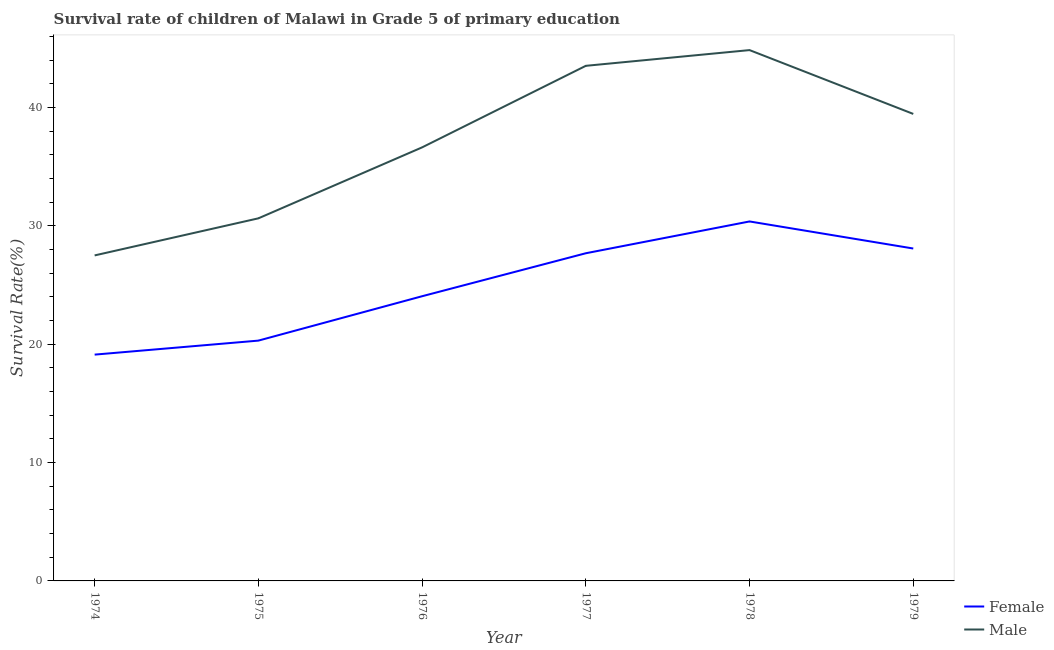How many different coloured lines are there?
Give a very brief answer. 2. Does the line corresponding to survival rate of female students in primary education intersect with the line corresponding to survival rate of male students in primary education?
Your response must be concise. No. Is the number of lines equal to the number of legend labels?
Keep it short and to the point. Yes. What is the survival rate of female students in primary education in 1979?
Ensure brevity in your answer.  28.09. Across all years, what is the maximum survival rate of female students in primary education?
Your response must be concise. 30.38. Across all years, what is the minimum survival rate of male students in primary education?
Ensure brevity in your answer.  27.51. In which year was the survival rate of female students in primary education maximum?
Ensure brevity in your answer.  1978. In which year was the survival rate of male students in primary education minimum?
Your answer should be very brief. 1974. What is the total survival rate of male students in primary education in the graph?
Make the answer very short. 222.64. What is the difference between the survival rate of male students in primary education in 1975 and that in 1976?
Provide a short and direct response. -6. What is the difference between the survival rate of female students in primary education in 1978 and the survival rate of male students in primary education in 1975?
Offer a terse response. -0.26. What is the average survival rate of female students in primary education per year?
Your answer should be compact. 24.94. In the year 1976, what is the difference between the survival rate of female students in primary education and survival rate of male students in primary education?
Offer a terse response. -12.58. In how many years, is the survival rate of female students in primary education greater than 16 %?
Your answer should be very brief. 6. What is the ratio of the survival rate of female students in primary education in 1975 to that in 1977?
Make the answer very short. 0.73. Is the difference between the survival rate of female students in primary education in 1978 and 1979 greater than the difference between the survival rate of male students in primary education in 1978 and 1979?
Keep it short and to the point. No. What is the difference between the highest and the second highest survival rate of male students in primary education?
Provide a short and direct response. 1.33. What is the difference between the highest and the lowest survival rate of male students in primary education?
Your response must be concise. 17.35. In how many years, is the survival rate of male students in primary education greater than the average survival rate of male students in primary education taken over all years?
Provide a succinct answer. 3. Is the sum of the survival rate of female students in primary education in 1976 and 1977 greater than the maximum survival rate of male students in primary education across all years?
Give a very brief answer. Yes. Does the survival rate of female students in primary education monotonically increase over the years?
Offer a very short reply. No. What is the difference between two consecutive major ticks on the Y-axis?
Your response must be concise. 10. Does the graph contain any zero values?
Your answer should be very brief. No. What is the title of the graph?
Your response must be concise. Survival rate of children of Malawi in Grade 5 of primary education. What is the label or title of the X-axis?
Provide a short and direct response. Year. What is the label or title of the Y-axis?
Ensure brevity in your answer.  Survival Rate(%). What is the Survival Rate(%) of Female in 1974?
Give a very brief answer. 19.12. What is the Survival Rate(%) of Male in 1974?
Give a very brief answer. 27.51. What is the Survival Rate(%) in Female in 1975?
Keep it short and to the point. 20.31. What is the Survival Rate(%) of Male in 1975?
Offer a terse response. 30.64. What is the Survival Rate(%) in Female in 1976?
Give a very brief answer. 24.06. What is the Survival Rate(%) of Male in 1976?
Provide a short and direct response. 36.64. What is the Survival Rate(%) of Female in 1977?
Ensure brevity in your answer.  27.69. What is the Survival Rate(%) in Male in 1977?
Provide a short and direct response. 43.53. What is the Survival Rate(%) of Female in 1978?
Provide a succinct answer. 30.38. What is the Survival Rate(%) in Male in 1978?
Provide a short and direct response. 44.86. What is the Survival Rate(%) of Female in 1979?
Give a very brief answer. 28.09. What is the Survival Rate(%) in Male in 1979?
Provide a short and direct response. 39.47. Across all years, what is the maximum Survival Rate(%) in Female?
Your answer should be very brief. 30.38. Across all years, what is the maximum Survival Rate(%) of Male?
Your answer should be very brief. 44.86. Across all years, what is the minimum Survival Rate(%) in Female?
Your response must be concise. 19.12. Across all years, what is the minimum Survival Rate(%) of Male?
Offer a terse response. 27.51. What is the total Survival Rate(%) of Female in the graph?
Ensure brevity in your answer.  149.65. What is the total Survival Rate(%) in Male in the graph?
Your answer should be compact. 222.64. What is the difference between the Survival Rate(%) of Female in 1974 and that in 1975?
Your answer should be very brief. -1.18. What is the difference between the Survival Rate(%) in Male in 1974 and that in 1975?
Offer a terse response. -3.13. What is the difference between the Survival Rate(%) in Female in 1974 and that in 1976?
Your answer should be compact. -4.93. What is the difference between the Survival Rate(%) of Male in 1974 and that in 1976?
Provide a short and direct response. -9.13. What is the difference between the Survival Rate(%) of Female in 1974 and that in 1977?
Give a very brief answer. -8.57. What is the difference between the Survival Rate(%) of Male in 1974 and that in 1977?
Keep it short and to the point. -16.02. What is the difference between the Survival Rate(%) of Female in 1974 and that in 1978?
Your answer should be very brief. -11.25. What is the difference between the Survival Rate(%) of Male in 1974 and that in 1978?
Provide a succinct answer. -17.35. What is the difference between the Survival Rate(%) in Female in 1974 and that in 1979?
Provide a short and direct response. -8.97. What is the difference between the Survival Rate(%) in Male in 1974 and that in 1979?
Offer a very short reply. -11.96. What is the difference between the Survival Rate(%) of Female in 1975 and that in 1976?
Provide a short and direct response. -3.75. What is the difference between the Survival Rate(%) in Male in 1975 and that in 1976?
Offer a terse response. -6. What is the difference between the Survival Rate(%) in Female in 1975 and that in 1977?
Your response must be concise. -7.38. What is the difference between the Survival Rate(%) of Male in 1975 and that in 1977?
Provide a short and direct response. -12.89. What is the difference between the Survival Rate(%) in Female in 1975 and that in 1978?
Offer a terse response. -10.07. What is the difference between the Survival Rate(%) of Male in 1975 and that in 1978?
Give a very brief answer. -14.22. What is the difference between the Survival Rate(%) of Female in 1975 and that in 1979?
Your answer should be very brief. -7.78. What is the difference between the Survival Rate(%) of Male in 1975 and that in 1979?
Your answer should be compact. -8.82. What is the difference between the Survival Rate(%) in Female in 1976 and that in 1977?
Keep it short and to the point. -3.63. What is the difference between the Survival Rate(%) in Male in 1976 and that in 1977?
Offer a terse response. -6.89. What is the difference between the Survival Rate(%) in Female in 1976 and that in 1978?
Give a very brief answer. -6.32. What is the difference between the Survival Rate(%) in Male in 1976 and that in 1978?
Offer a terse response. -8.22. What is the difference between the Survival Rate(%) of Female in 1976 and that in 1979?
Keep it short and to the point. -4.03. What is the difference between the Survival Rate(%) in Male in 1976 and that in 1979?
Your answer should be very brief. -2.83. What is the difference between the Survival Rate(%) in Female in 1977 and that in 1978?
Provide a succinct answer. -2.69. What is the difference between the Survival Rate(%) in Male in 1977 and that in 1978?
Your response must be concise. -1.33. What is the difference between the Survival Rate(%) of Female in 1977 and that in 1979?
Provide a succinct answer. -0.4. What is the difference between the Survival Rate(%) of Male in 1977 and that in 1979?
Provide a succinct answer. 4.06. What is the difference between the Survival Rate(%) of Female in 1978 and that in 1979?
Offer a terse response. 2.29. What is the difference between the Survival Rate(%) of Male in 1978 and that in 1979?
Your response must be concise. 5.39. What is the difference between the Survival Rate(%) in Female in 1974 and the Survival Rate(%) in Male in 1975?
Provide a short and direct response. -11.52. What is the difference between the Survival Rate(%) in Female in 1974 and the Survival Rate(%) in Male in 1976?
Your response must be concise. -17.51. What is the difference between the Survival Rate(%) of Female in 1974 and the Survival Rate(%) of Male in 1977?
Provide a succinct answer. -24.41. What is the difference between the Survival Rate(%) in Female in 1974 and the Survival Rate(%) in Male in 1978?
Your answer should be compact. -25.73. What is the difference between the Survival Rate(%) in Female in 1974 and the Survival Rate(%) in Male in 1979?
Offer a very short reply. -20.34. What is the difference between the Survival Rate(%) of Female in 1975 and the Survival Rate(%) of Male in 1976?
Offer a very short reply. -16.33. What is the difference between the Survival Rate(%) in Female in 1975 and the Survival Rate(%) in Male in 1977?
Provide a short and direct response. -23.22. What is the difference between the Survival Rate(%) of Female in 1975 and the Survival Rate(%) of Male in 1978?
Your answer should be compact. -24.55. What is the difference between the Survival Rate(%) of Female in 1975 and the Survival Rate(%) of Male in 1979?
Keep it short and to the point. -19.16. What is the difference between the Survival Rate(%) of Female in 1976 and the Survival Rate(%) of Male in 1977?
Your response must be concise. -19.47. What is the difference between the Survival Rate(%) in Female in 1976 and the Survival Rate(%) in Male in 1978?
Give a very brief answer. -20.8. What is the difference between the Survival Rate(%) in Female in 1976 and the Survival Rate(%) in Male in 1979?
Your response must be concise. -15.41. What is the difference between the Survival Rate(%) of Female in 1977 and the Survival Rate(%) of Male in 1978?
Make the answer very short. -17.17. What is the difference between the Survival Rate(%) in Female in 1977 and the Survival Rate(%) in Male in 1979?
Your answer should be very brief. -11.77. What is the difference between the Survival Rate(%) in Female in 1978 and the Survival Rate(%) in Male in 1979?
Provide a short and direct response. -9.09. What is the average Survival Rate(%) in Female per year?
Offer a very short reply. 24.94. What is the average Survival Rate(%) in Male per year?
Ensure brevity in your answer.  37.11. In the year 1974, what is the difference between the Survival Rate(%) in Female and Survival Rate(%) in Male?
Your answer should be very brief. -8.38. In the year 1975, what is the difference between the Survival Rate(%) of Female and Survival Rate(%) of Male?
Provide a succinct answer. -10.33. In the year 1976, what is the difference between the Survival Rate(%) of Female and Survival Rate(%) of Male?
Make the answer very short. -12.58. In the year 1977, what is the difference between the Survival Rate(%) in Female and Survival Rate(%) in Male?
Provide a short and direct response. -15.84. In the year 1978, what is the difference between the Survival Rate(%) in Female and Survival Rate(%) in Male?
Keep it short and to the point. -14.48. In the year 1979, what is the difference between the Survival Rate(%) in Female and Survival Rate(%) in Male?
Provide a short and direct response. -11.37. What is the ratio of the Survival Rate(%) in Female in 1974 to that in 1975?
Make the answer very short. 0.94. What is the ratio of the Survival Rate(%) in Male in 1974 to that in 1975?
Offer a terse response. 0.9. What is the ratio of the Survival Rate(%) in Female in 1974 to that in 1976?
Give a very brief answer. 0.79. What is the ratio of the Survival Rate(%) of Male in 1974 to that in 1976?
Provide a short and direct response. 0.75. What is the ratio of the Survival Rate(%) in Female in 1974 to that in 1977?
Your answer should be compact. 0.69. What is the ratio of the Survival Rate(%) of Male in 1974 to that in 1977?
Your answer should be compact. 0.63. What is the ratio of the Survival Rate(%) of Female in 1974 to that in 1978?
Ensure brevity in your answer.  0.63. What is the ratio of the Survival Rate(%) of Male in 1974 to that in 1978?
Offer a very short reply. 0.61. What is the ratio of the Survival Rate(%) in Female in 1974 to that in 1979?
Your answer should be compact. 0.68. What is the ratio of the Survival Rate(%) of Male in 1974 to that in 1979?
Offer a terse response. 0.7. What is the ratio of the Survival Rate(%) in Female in 1975 to that in 1976?
Offer a terse response. 0.84. What is the ratio of the Survival Rate(%) of Male in 1975 to that in 1976?
Offer a terse response. 0.84. What is the ratio of the Survival Rate(%) of Female in 1975 to that in 1977?
Offer a terse response. 0.73. What is the ratio of the Survival Rate(%) of Male in 1975 to that in 1977?
Offer a very short reply. 0.7. What is the ratio of the Survival Rate(%) in Female in 1975 to that in 1978?
Keep it short and to the point. 0.67. What is the ratio of the Survival Rate(%) of Male in 1975 to that in 1978?
Your response must be concise. 0.68. What is the ratio of the Survival Rate(%) in Female in 1975 to that in 1979?
Ensure brevity in your answer.  0.72. What is the ratio of the Survival Rate(%) in Male in 1975 to that in 1979?
Provide a short and direct response. 0.78. What is the ratio of the Survival Rate(%) of Female in 1976 to that in 1977?
Offer a very short reply. 0.87. What is the ratio of the Survival Rate(%) of Male in 1976 to that in 1977?
Provide a succinct answer. 0.84. What is the ratio of the Survival Rate(%) of Female in 1976 to that in 1978?
Give a very brief answer. 0.79. What is the ratio of the Survival Rate(%) of Male in 1976 to that in 1978?
Make the answer very short. 0.82. What is the ratio of the Survival Rate(%) in Female in 1976 to that in 1979?
Offer a very short reply. 0.86. What is the ratio of the Survival Rate(%) in Male in 1976 to that in 1979?
Provide a short and direct response. 0.93. What is the ratio of the Survival Rate(%) of Female in 1977 to that in 1978?
Your answer should be very brief. 0.91. What is the ratio of the Survival Rate(%) in Male in 1977 to that in 1978?
Your answer should be compact. 0.97. What is the ratio of the Survival Rate(%) of Female in 1977 to that in 1979?
Offer a terse response. 0.99. What is the ratio of the Survival Rate(%) in Male in 1977 to that in 1979?
Keep it short and to the point. 1.1. What is the ratio of the Survival Rate(%) of Female in 1978 to that in 1979?
Your answer should be very brief. 1.08. What is the ratio of the Survival Rate(%) in Male in 1978 to that in 1979?
Ensure brevity in your answer.  1.14. What is the difference between the highest and the second highest Survival Rate(%) in Female?
Give a very brief answer. 2.29. What is the difference between the highest and the second highest Survival Rate(%) of Male?
Give a very brief answer. 1.33. What is the difference between the highest and the lowest Survival Rate(%) of Female?
Offer a terse response. 11.25. What is the difference between the highest and the lowest Survival Rate(%) in Male?
Your answer should be very brief. 17.35. 